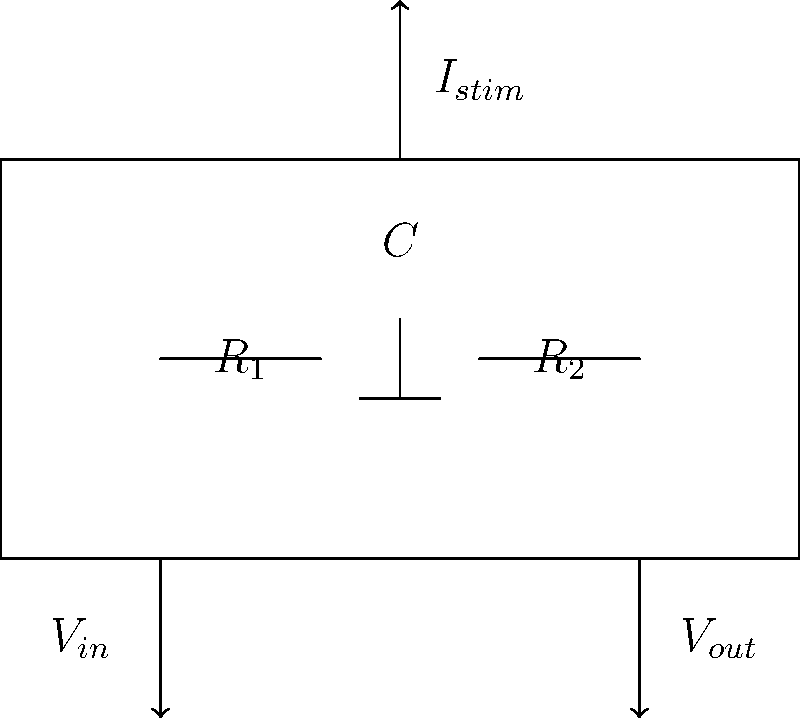In the given circuit diagram of a simplified neurostimulation device, $R_1 = 10$ kΩ, $R_2 = 20$ kΩ, and $C = 100$ μF. If the input voltage $V_{in}$ is a 5V square wave with a frequency of 100 Hz, calculate the maximum stimulation current $I_{stim}$ that can be delivered to the neural tissue. To solve this problem, we'll follow these steps:

1) First, we need to understand that the maximum current will occur when the capacitor is fully charged, which happens at the peak of the square wave.

2) At this point, the circuit behaves like a simple voltage divider, as the capacitor acts like an open circuit for DC.

3) The voltage across $R_2$ (which is $V_{out}$) can be calculated using the voltage divider formula:

   $$V_{out} = V_{in} \cdot \frac{R_2}{R_1 + R_2}$$

4) Substituting the values:

   $$V_{out} = 5V \cdot \frac{20k\Omega}{10k\Omega + 20k\Omega} = 3.33V$$

5) The stimulation current $I_{stim}$ is the current flowing through $R_2$, which can be calculated using Ohm's law:

   $$I_{stim} = \frac{V_{out}}{R_2}$$

6) Substituting the values:

   $$I_{stim} = \frac{3.33V}{20k\Omega} = 166.5 \mu A$$

Therefore, the maximum stimulation current that can be delivered to the neural tissue is 166.5 μA.
Answer: 166.5 μA 